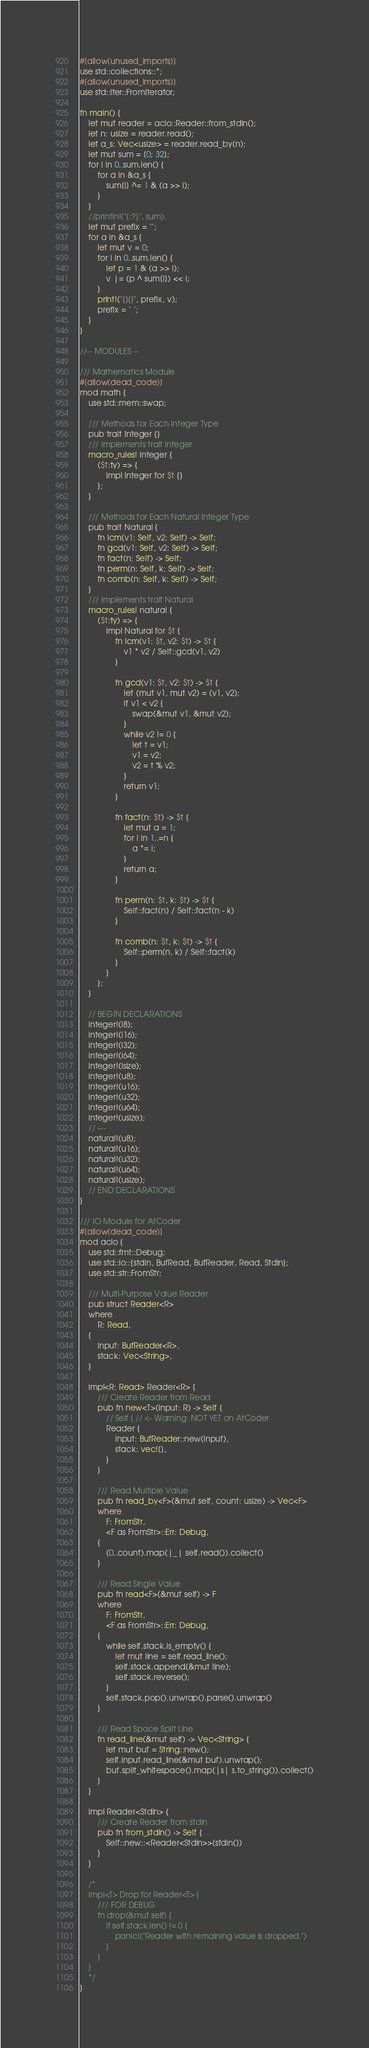<code> <loc_0><loc_0><loc_500><loc_500><_Rust_>#[allow(unused_imports)]
use std::collections::*;
#[allow(unused_imports)]
use std::iter::FromIterator;

fn main() {
    let mut reader = acio::Reader::from_stdin();
    let n: usize = reader.read();
    let a_s: Vec<usize> = reader.read_by(n);
    let mut sum = [0; 32];
    for i in 0..sum.len() {
        for a in &a_s {
            sum[i] ^= 1 & (a >> i);
        }
    }
    //println!("{:?}", sum);
    let mut prefix = "";
    for a in &a_s {
        let mut v = 0;
        for i in 0..sum.len() {
            let p = 1 & (a >> i);
            v |= (p ^ sum[i]) << i;
        }
        print!("{}{}", prefix, v);
        prefix = " ";
    }
}

//-- MODULES --

/// Mathematics Module
#[allow(dead_code)]
mod math {
    use std::mem::swap;

    /// Methods for Each Integer Type
    pub trait Integer {}
    /// Implements trait Integer
    macro_rules! integer {
        ($t:ty) => {
            impl Integer for $t {}
        };
    }

    /// Methods for Each Natural Integer Type
    pub trait Natural {
        fn lcm(v1: Self, v2: Self) -> Self;
        fn gcd(v1: Self, v2: Self) -> Self;
        fn fact(n: Self) -> Self;
        fn perm(n: Self, k: Self) -> Self;
        fn comb(n: Self, k: Self) -> Self;
    }
    /// Implements trait Natural
    macro_rules! natural {
        ($t:ty) => {
            impl Natural for $t {
                fn lcm(v1: $t, v2: $t) -> $t {
                    v1 * v2 / Self::gcd(v1, v2)
                }

                fn gcd(v1: $t, v2: $t) -> $t {
                    let (mut v1, mut v2) = (v1, v2);
                    if v1 < v2 {
                        swap(&mut v1, &mut v2);
                    }
                    while v2 != 0 {
                        let t = v1;
                        v1 = v2;
                        v2 = t % v2;
                    }
                    return v1;
                }

                fn fact(n: $t) -> $t {
                    let mut a = 1;
                    for i in 1..=n {
                        a *= i;
                    }
                    return a;
                }

                fn perm(n: $t, k: $t) -> $t {
                    Self::fact(n) / Self::fact(n - k)
                }

                fn comb(n: $t, k: $t) -> $t {
                    Self::perm(n, k) / Self::fact(k)
                }
            }
        };
    }

    // BEGIN DECLARATIONS
    integer!(i8);
    integer!(i16);
    integer!(i32);
    integer!(i64);
    integer!(isize);
    integer!(u8);
    integer!(u16);
    integer!(u32);
    integer!(u64);
    integer!(usize);
    // ---
    natural!(u8);
    natural!(u16);
    natural!(u32);
    natural!(u64);
    natural!(usize);
    // END DECLARATIONS
}

/// IO Module for AtCoder
#[allow(dead_code)]
mod acio {
    use std::fmt::Debug;
    use std::io::{stdin, BufRead, BufReader, Read, Stdin};
    use std::str::FromStr;

    /// Multi-Purpose Value Reader
    pub struct Reader<R>
    where
        R: Read,
    {
        input: BufReader<R>,
        stack: Vec<String>,
    }

    impl<R: Read> Reader<R> {
        /// Create Reader from Read
        pub fn new<T>(input: R) -> Self {
            // Self { // <- Warning: NOT YET on AtCoder
            Reader {
                input: BufReader::new(input),
                stack: vec![],
            }
        }

        /// Read Multiple Value
        pub fn read_by<F>(&mut self, count: usize) -> Vec<F>
        where
            F: FromStr,
            <F as FromStr>::Err: Debug,
        {
            (0..count).map(|_| self.read()).collect()
        }

        /// Read Single Value
        pub fn read<F>(&mut self) -> F
        where
            F: FromStr,
            <F as FromStr>::Err: Debug,
        {
            while self.stack.is_empty() {
                let mut line = self.read_line();
                self.stack.append(&mut line);
                self.stack.reverse();
            }
            self.stack.pop().unwrap().parse().unwrap()
        }

        /// Read Space Split Line
        fn read_line(&mut self) -> Vec<String> {
            let mut buf = String::new();
            self.input.read_line(&mut buf).unwrap();
            buf.split_whitespace().map(|s| s.to_string()).collect()
        }
    }

    impl Reader<Stdin> {
        /// Create Reader from stdin
        pub fn from_stdin() -> Self {
            Self::new::<Reader<Stdin>>(stdin())
        }
    }

    /*
    impl<T> Drop for Reader<T> {
        /// FOR DEBUG
        fn drop(&mut self) {
            if self.stack.len() != 0 {
                panic!("Reader with remaining value is dropped.")
            }
        }
    }
    */
}
</code> 